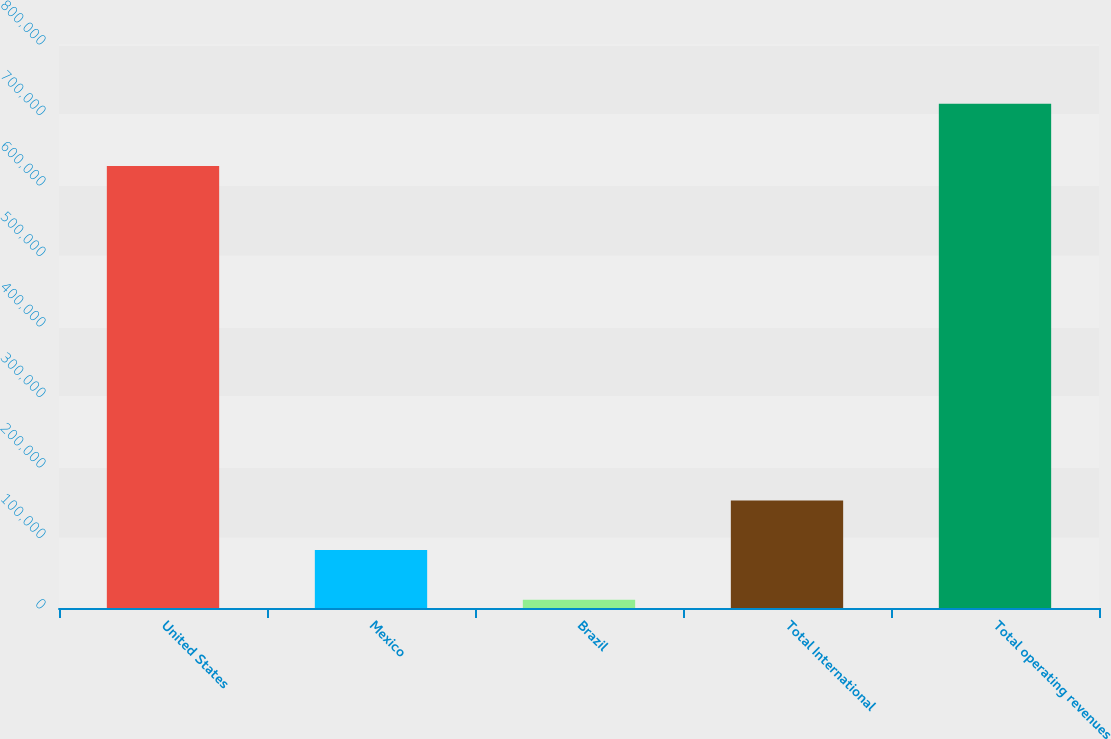<chart> <loc_0><loc_0><loc_500><loc_500><bar_chart><fcel>United States<fcel>Mexico<fcel>Brazil<fcel>Total International<fcel>Total operating revenues<nl><fcel>627049<fcel>82107.4<fcel>11770<fcel>152445<fcel>715144<nl></chart> 